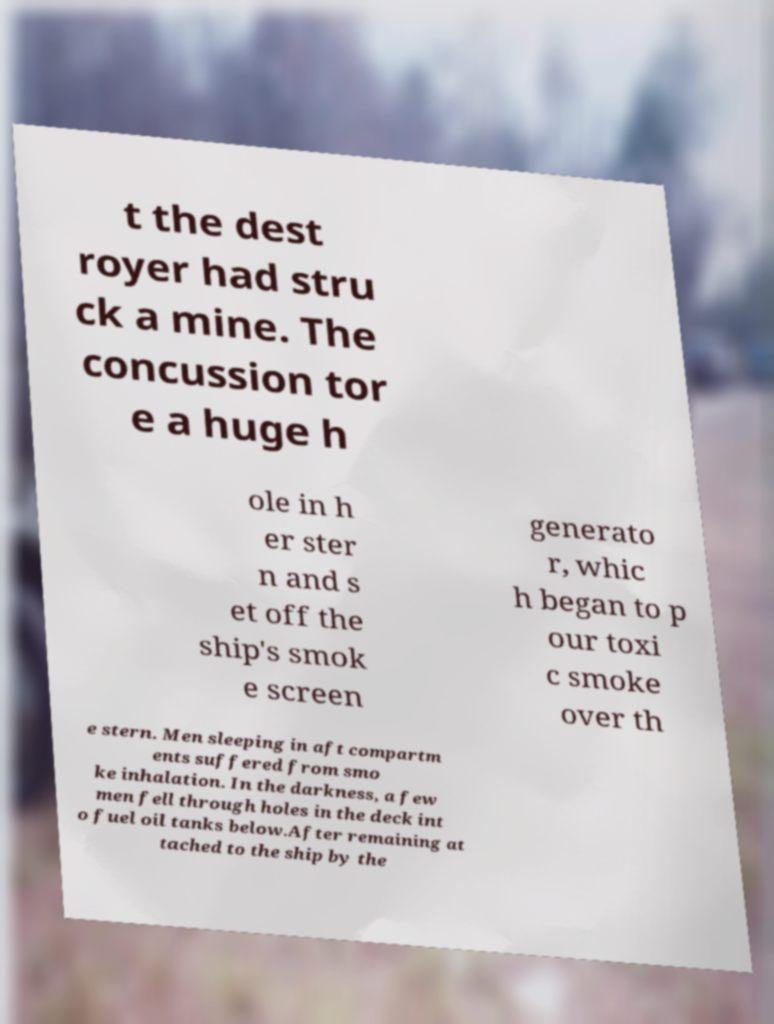Could you extract and type out the text from this image? t the dest royer had stru ck a mine. The concussion tor e a huge h ole in h er ster n and s et off the ship's smok e screen generato r, whic h began to p our toxi c smoke over th e stern. Men sleeping in aft compartm ents suffered from smo ke inhalation. In the darkness, a few men fell through holes in the deck int o fuel oil tanks below.After remaining at tached to the ship by the 